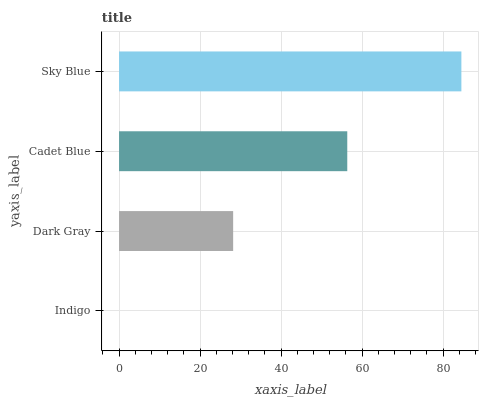Is Indigo the minimum?
Answer yes or no. Yes. Is Sky Blue the maximum?
Answer yes or no. Yes. Is Dark Gray the minimum?
Answer yes or no. No. Is Dark Gray the maximum?
Answer yes or no. No. Is Dark Gray greater than Indigo?
Answer yes or no. Yes. Is Indigo less than Dark Gray?
Answer yes or no. Yes. Is Indigo greater than Dark Gray?
Answer yes or no. No. Is Dark Gray less than Indigo?
Answer yes or no. No. Is Cadet Blue the high median?
Answer yes or no. Yes. Is Dark Gray the low median?
Answer yes or no. Yes. Is Dark Gray the high median?
Answer yes or no. No. Is Indigo the low median?
Answer yes or no. No. 